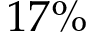Convert formula to latex. <formula><loc_0><loc_0><loc_500><loc_500>1 7 \%</formula> 